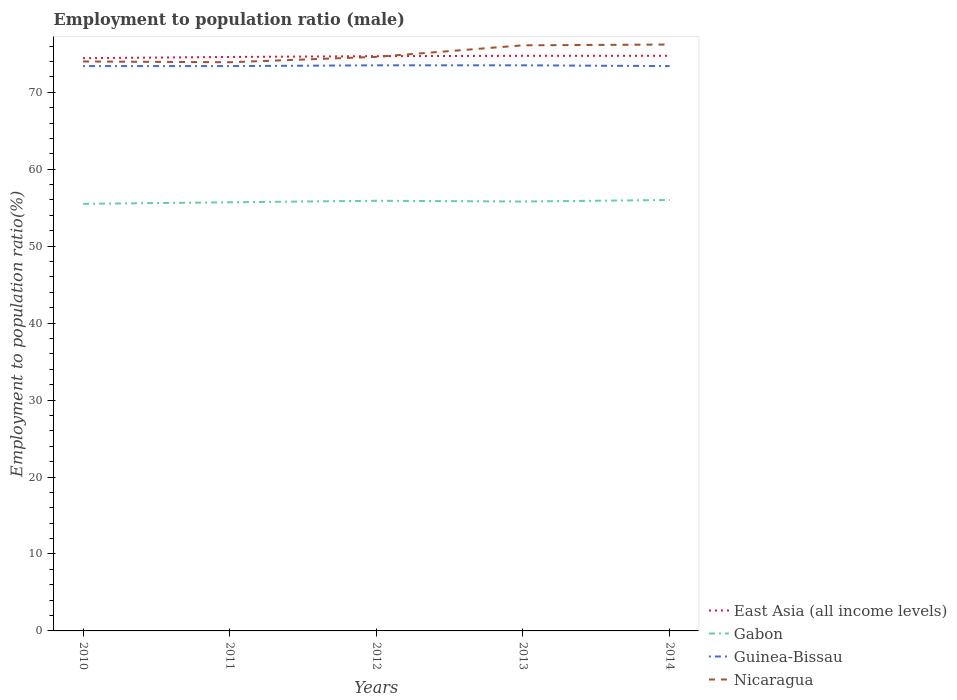How many different coloured lines are there?
Provide a succinct answer. 4. Does the line corresponding to Gabon intersect with the line corresponding to Nicaragua?
Make the answer very short. No. Across all years, what is the maximum employment to population ratio in Gabon?
Offer a terse response. 55.5. What is the total employment to population ratio in Nicaragua in the graph?
Offer a terse response. -0.7. What is the difference between the highest and the second highest employment to population ratio in Nicaragua?
Offer a terse response. 2.3. Is the employment to population ratio in Nicaragua strictly greater than the employment to population ratio in Guinea-Bissau over the years?
Ensure brevity in your answer.  No. How many years are there in the graph?
Provide a succinct answer. 5. Does the graph contain grids?
Keep it short and to the point. No. What is the title of the graph?
Your answer should be very brief. Employment to population ratio (male). Does "Venezuela" appear as one of the legend labels in the graph?
Ensure brevity in your answer.  No. What is the Employment to population ratio(%) of East Asia (all income levels) in 2010?
Offer a terse response. 74.43. What is the Employment to population ratio(%) in Gabon in 2010?
Make the answer very short. 55.5. What is the Employment to population ratio(%) of Guinea-Bissau in 2010?
Give a very brief answer. 73.4. What is the Employment to population ratio(%) of Nicaragua in 2010?
Ensure brevity in your answer.  74. What is the Employment to population ratio(%) of East Asia (all income levels) in 2011?
Provide a short and direct response. 74.59. What is the Employment to population ratio(%) of Gabon in 2011?
Your answer should be very brief. 55.7. What is the Employment to population ratio(%) of Guinea-Bissau in 2011?
Your answer should be compact. 73.4. What is the Employment to population ratio(%) of Nicaragua in 2011?
Your answer should be very brief. 73.9. What is the Employment to population ratio(%) in East Asia (all income levels) in 2012?
Make the answer very short. 74.69. What is the Employment to population ratio(%) of Gabon in 2012?
Ensure brevity in your answer.  55.9. What is the Employment to population ratio(%) of Guinea-Bissau in 2012?
Make the answer very short. 73.5. What is the Employment to population ratio(%) in Nicaragua in 2012?
Provide a succinct answer. 74.6. What is the Employment to population ratio(%) in East Asia (all income levels) in 2013?
Offer a terse response. 74.74. What is the Employment to population ratio(%) in Gabon in 2013?
Keep it short and to the point. 55.8. What is the Employment to population ratio(%) of Guinea-Bissau in 2013?
Offer a terse response. 73.5. What is the Employment to population ratio(%) of Nicaragua in 2013?
Offer a very short reply. 76.1. What is the Employment to population ratio(%) in East Asia (all income levels) in 2014?
Your response must be concise. 74.74. What is the Employment to population ratio(%) of Gabon in 2014?
Your response must be concise. 56. What is the Employment to population ratio(%) in Guinea-Bissau in 2014?
Your answer should be compact. 73.4. What is the Employment to population ratio(%) in Nicaragua in 2014?
Provide a short and direct response. 76.2. Across all years, what is the maximum Employment to population ratio(%) of East Asia (all income levels)?
Your answer should be compact. 74.74. Across all years, what is the maximum Employment to population ratio(%) of Gabon?
Keep it short and to the point. 56. Across all years, what is the maximum Employment to population ratio(%) of Guinea-Bissau?
Provide a succinct answer. 73.5. Across all years, what is the maximum Employment to population ratio(%) in Nicaragua?
Your answer should be very brief. 76.2. Across all years, what is the minimum Employment to population ratio(%) of East Asia (all income levels)?
Your response must be concise. 74.43. Across all years, what is the minimum Employment to population ratio(%) of Gabon?
Your answer should be very brief. 55.5. Across all years, what is the minimum Employment to population ratio(%) of Guinea-Bissau?
Make the answer very short. 73.4. Across all years, what is the minimum Employment to population ratio(%) in Nicaragua?
Provide a short and direct response. 73.9. What is the total Employment to population ratio(%) of East Asia (all income levels) in the graph?
Make the answer very short. 373.17. What is the total Employment to population ratio(%) in Gabon in the graph?
Offer a terse response. 278.9. What is the total Employment to population ratio(%) of Guinea-Bissau in the graph?
Your response must be concise. 367.2. What is the total Employment to population ratio(%) of Nicaragua in the graph?
Ensure brevity in your answer.  374.8. What is the difference between the Employment to population ratio(%) in East Asia (all income levels) in 2010 and that in 2011?
Your response must be concise. -0.16. What is the difference between the Employment to population ratio(%) in Nicaragua in 2010 and that in 2011?
Make the answer very short. 0.1. What is the difference between the Employment to population ratio(%) in East Asia (all income levels) in 2010 and that in 2012?
Your response must be concise. -0.26. What is the difference between the Employment to population ratio(%) in East Asia (all income levels) in 2010 and that in 2013?
Offer a terse response. -0.31. What is the difference between the Employment to population ratio(%) in Gabon in 2010 and that in 2013?
Offer a terse response. -0.3. What is the difference between the Employment to population ratio(%) of Guinea-Bissau in 2010 and that in 2013?
Your response must be concise. -0.1. What is the difference between the Employment to population ratio(%) of Nicaragua in 2010 and that in 2013?
Give a very brief answer. -2.1. What is the difference between the Employment to population ratio(%) of East Asia (all income levels) in 2010 and that in 2014?
Offer a very short reply. -0.31. What is the difference between the Employment to population ratio(%) of Nicaragua in 2010 and that in 2014?
Your answer should be compact. -2.2. What is the difference between the Employment to population ratio(%) in East Asia (all income levels) in 2011 and that in 2012?
Your answer should be compact. -0.1. What is the difference between the Employment to population ratio(%) of Gabon in 2011 and that in 2012?
Provide a succinct answer. -0.2. What is the difference between the Employment to population ratio(%) in Nicaragua in 2011 and that in 2012?
Your answer should be compact. -0.7. What is the difference between the Employment to population ratio(%) of East Asia (all income levels) in 2011 and that in 2013?
Make the answer very short. -0.15. What is the difference between the Employment to population ratio(%) of Guinea-Bissau in 2011 and that in 2013?
Make the answer very short. -0.1. What is the difference between the Employment to population ratio(%) in East Asia (all income levels) in 2011 and that in 2014?
Offer a very short reply. -0.15. What is the difference between the Employment to population ratio(%) in Nicaragua in 2011 and that in 2014?
Keep it short and to the point. -2.3. What is the difference between the Employment to population ratio(%) in East Asia (all income levels) in 2012 and that in 2013?
Provide a short and direct response. -0.05. What is the difference between the Employment to population ratio(%) of Gabon in 2012 and that in 2013?
Offer a terse response. 0.1. What is the difference between the Employment to population ratio(%) of Guinea-Bissau in 2012 and that in 2013?
Your response must be concise. 0. What is the difference between the Employment to population ratio(%) in East Asia (all income levels) in 2012 and that in 2014?
Your answer should be very brief. -0.05. What is the difference between the Employment to population ratio(%) in Guinea-Bissau in 2012 and that in 2014?
Your response must be concise. 0.1. What is the difference between the Employment to population ratio(%) of East Asia (all income levels) in 2013 and that in 2014?
Offer a terse response. -0. What is the difference between the Employment to population ratio(%) of Guinea-Bissau in 2013 and that in 2014?
Give a very brief answer. 0.1. What is the difference between the Employment to population ratio(%) in Nicaragua in 2013 and that in 2014?
Keep it short and to the point. -0.1. What is the difference between the Employment to population ratio(%) of East Asia (all income levels) in 2010 and the Employment to population ratio(%) of Gabon in 2011?
Offer a very short reply. 18.73. What is the difference between the Employment to population ratio(%) of East Asia (all income levels) in 2010 and the Employment to population ratio(%) of Guinea-Bissau in 2011?
Your answer should be very brief. 1.03. What is the difference between the Employment to population ratio(%) in East Asia (all income levels) in 2010 and the Employment to population ratio(%) in Nicaragua in 2011?
Your response must be concise. 0.53. What is the difference between the Employment to population ratio(%) in Gabon in 2010 and the Employment to population ratio(%) in Guinea-Bissau in 2011?
Ensure brevity in your answer.  -17.9. What is the difference between the Employment to population ratio(%) of Gabon in 2010 and the Employment to population ratio(%) of Nicaragua in 2011?
Provide a succinct answer. -18.4. What is the difference between the Employment to population ratio(%) of East Asia (all income levels) in 2010 and the Employment to population ratio(%) of Gabon in 2012?
Your answer should be compact. 18.53. What is the difference between the Employment to population ratio(%) in East Asia (all income levels) in 2010 and the Employment to population ratio(%) in Guinea-Bissau in 2012?
Keep it short and to the point. 0.93. What is the difference between the Employment to population ratio(%) in East Asia (all income levels) in 2010 and the Employment to population ratio(%) in Nicaragua in 2012?
Provide a succinct answer. -0.17. What is the difference between the Employment to population ratio(%) in Gabon in 2010 and the Employment to population ratio(%) in Nicaragua in 2012?
Your answer should be very brief. -19.1. What is the difference between the Employment to population ratio(%) of Guinea-Bissau in 2010 and the Employment to population ratio(%) of Nicaragua in 2012?
Offer a terse response. -1.2. What is the difference between the Employment to population ratio(%) in East Asia (all income levels) in 2010 and the Employment to population ratio(%) in Gabon in 2013?
Your answer should be compact. 18.63. What is the difference between the Employment to population ratio(%) in East Asia (all income levels) in 2010 and the Employment to population ratio(%) in Guinea-Bissau in 2013?
Offer a very short reply. 0.93. What is the difference between the Employment to population ratio(%) in East Asia (all income levels) in 2010 and the Employment to population ratio(%) in Nicaragua in 2013?
Offer a terse response. -1.67. What is the difference between the Employment to population ratio(%) of Gabon in 2010 and the Employment to population ratio(%) of Guinea-Bissau in 2013?
Ensure brevity in your answer.  -18. What is the difference between the Employment to population ratio(%) of Gabon in 2010 and the Employment to population ratio(%) of Nicaragua in 2013?
Give a very brief answer. -20.6. What is the difference between the Employment to population ratio(%) in Guinea-Bissau in 2010 and the Employment to population ratio(%) in Nicaragua in 2013?
Your answer should be compact. -2.7. What is the difference between the Employment to population ratio(%) of East Asia (all income levels) in 2010 and the Employment to population ratio(%) of Gabon in 2014?
Give a very brief answer. 18.43. What is the difference between the Employment to population ratio(%) of East Asia (all income levels) in 2010 and the Employment to population ratio(%) of Guinea-Bissau in 2014?
Make the answer very short. 1.03. What is the difference between the Employment to population ratio(%) in East Asia (all income levels) in 2010 and the Employment to population ratio(%) in Nicaragua in 2014?
Your answer should be very brief. -1.77. What is the difference between the Employment to population ratio(%) in Gabon in 2010 and the Employment to population ratio(%) in Guinea-Bissau in 2014?
Your answer should be compact. -17.9. What is the difference between the Employment to population ratio(%) in Gabon in 2010 and the Employment to population ratio(%) in Nicaragua in 2014?
Offer a terse response. -20.7. What is the difference between the Employment to population ratio(%) in Guinea-Bissau in 2010 and the Employment to population ratio(%) in Nicaragua in 2014?
Your answer should be very brief. -2.8. What is the difference between the Employment to population ratio(%) of East Asia (all income levels) in 2011 and the Employment to population ratio(%) of Gabon in 2012?
Offer a very short reply. 18.69. What is the difference between the Employment to population ratio(%) in East Asia (all income levels) in 2011 and the Employment to population ratio(%) in Guinea-Bissau in 2012?
Offer a very short reply. 1.09. What is the difference between the Employment to population ratio(%) in East Asia (all income levels) in 2011 and the Employment to population ratio(%) in Nicaragua in 2012?
Give a very brief answer. -0.01. What is the difference between the Employment to population ratio(%) of Gabon in 2011 and the Employment to population ratio(%) of Guinea-Bissau in 2012?
Offer a very short reply. -17.8. What is the difference between the Employment to population ratio(%) of Gabon in 2011 and the Employment to population ratio(%) of Nicaragua in 2012?
Make the answer very short. -18.9. What is the difference between the Employment to population ratio(%) in East Asia (all income levels) in 2011 and the Employment to population ratio(%) in Gabon in 2013?
Provide a succinct answer. 18.79. What is the difference between the Employment to population ratio(%) in East Asia (all income levels) in 2011 and the Employment to population ratio(%) in Guinea-Bissau in 2013?
Your answer should be compact. 1.09. What is the difference between the Employment to population ratio(%) in East Asia (all income levels) in 2011 and the Employment to population ratio(%) in Nicaragua in 2013?
Ensure brevity in your answer.  -1.51. What is the difference between the Employment to population ratio(%) in Gabon in 2011 and the Employment to population ratio(%) in Guinea-Bissau in 2013?
Provide a short and direct response. -17.8. What is the difference between the Employment to population ratio(%) in Gabon in 2011 and the Employment to population ratio(%) in Nicaragua in 2013?
Give a very brief answer. -20.4. What is the difference between the Employment to population ratio(%) of Guinea-Bissau in 2011 and the Employment to population ratio(%) of Nicaragua in 2013?
Your answer should be very brief. -2.7. What is the difference between the Employment to population ratio(%) of East Asia (all income levels) in 2011 and the Employment to population ratio(%) of Gabon in 2014?
Your answer should be very brief. 18.59. What is the difference between the Employment to population ratio(%) of East Asia (all income levels) in 2011 and the Employment to population ratio(%) of Guinea-Bissau in 2014?
Offer a terse response. 1.19. What is the difference between the Employment to population ratio(%) of East Asia (all income levels) in 2011 and the Employment to population ratio(%) of Nicaragua in 2014?
Provide a succinct answer. -1.61. What is the difference between the Employment to population ratio(%) of Gabon in 2011 and the Employment to population ratio(%) of Guinea-Bissau in 2014?
Offer a very short reply. -17.7. What is the difference between the Employment to population ratio(%) of Gabon in 2011 and the Employment to population ratio(%) of Nicaragua in 2014?
Offer a terse response. -20.5. What is the difference between the Employment to population ratio(%) in Guinea-Bissau in 2011 and the Employment to population ratio(%) in Nicaragua in 2014?
Provide a short and direct response. -2.8. What is the difference between the Employment to population ratio(%) in East Asia (all income levels) in 2012 and the Employment to population ratio(%) in Gabon in 2013?
Offer a terse response. 18.89. What is the difference between the Employment to population ratio(%) of East Asia (all income levels) in 2012 and the Employment to population ratio(%) of Guinea-Bissau in 2013?
Your response must be concise. 1.19. What is the difference between the Employment to population ratio(%) in East Asia (all income levels) in 2012 and the Employment to population ratio(%) in Nicaragua in 2013?
Ensure brevity in your answer.  -1.41. What is the difference between the Employment to population ratio(%) in Gabon in 2012 and the Employment to population ratio(%) in Guinea-Bissau in 2013?
Keep it short and to the point. -17.6. What is the difference between the Employment to population ratio(%) in Gabon in 2012 and the Employment to population ratio(%) in Nicaragua in 2013?
Offer a terse response. -20.2. What is the difference between the Employment to population ratio(%) of Guinea-Bissau in 2012 and the Employment to population ratio(%) of Nicaragua in 2013?
Your answer should be very brief. -2.6. What is the difference between the Employment to population ratio(%) of East Asia (all income levels) in 2012 and the Employment to population ratio(%) of Gabon in 2014?
Give a very brief answer. 18.69. What is the difference between the Employment to population ratio(%) of East Asia (all income levels) in 2012 and the Employment to population ratio(%) of Guinea-Bissau in 2014?
Your answer should be compact. 1.29. What is the difference between the Employment to population ratio(%) of East Asia (all income levels) in 2012 and the Employment to population ratio(%) of Nicaragua in 2014?
Give a very brief answer. -1.51. What is the difference between the Employment to population ratio(%) in Gabon in 2012 and the Employment to population ratio(%) in Guinea-Bissau in 2014?
Your answer should be compact. -17.5. What is the difference between the Employment to population ratio(%) of Gabon in 2012 and the Employment to population ratio(%) of Nicaragua in 2014?
Keep it short and to the point. -20.3. What is the difference between the Employment to population ratio(%) in East Asia (all income levels) in 2013 and the Employment to population ratio(%) in Gabon in 2014?
Provide a short and direct response. 18.74. What is the difference between the Employment to population ratio(%) of East Asia (all income levels) in 2013 and the Employment to population ratio(%) of Guinea-Bissau in 2014?
Provide a succinct answer. 1.34. What is the difference between the Employment to population ratio(%) in East Asia (all income levels) in 2013 and the Employment to population ratio(%) in Nicaragua in 2014?
Ensure brevity in your answer.  -1.46. What is the difference between the Employment to population ratio(%) of Gabon in 2013 and the Employment to population ratio(%) of Guinea-Bissau in 2014?
Your answer should be very brief. -17.6. What is the difference between the Employment to population ratio(%) in Gabon in 2013 and the Employment to population ratio(%) in Nicaragua in 2014?
Provide a succinct answer. -20.4. What is the average Employment to population ratio(%) in East Asia (all income levels) per year?
Provide a short and direct response. 74.64. What is the average Employment to population ratio(%) of Gabon per year?
Offer a very short reply. 55.78. What is the average Employment to population ratio(%) of Guinea-Bissau per year?
Your response must be concise. 73.44. What is the average Employment to population ratio(%) of Nicaragua per year?
Your answer should be compact. 74.96. In the year 2010, what is the difference between the Employment to population ratio(%) of East Asia (all income levels) and Employment to population ratio(%) of Gabon?
Provide a succinct answer. 18.93. In the year 2010, what is the difference between the Employment to population ratio(%) of East Asia (all income levels) and Employment to population ratio(%) of Guinea-Bissau?
Keep it short and to the point. 1.03. In the year 2010, what is the difference between the Employment to population ratio(%) of East Asia (all income levels) and Employment to population ratio(%) of Nicaragua?
Keep it short and to the point. 0.43. In the year 2010, what is the difference between the Employment to population ratio(%) in Gabon and Employment to population ratio(%) in Guinea-Bissau?
Offer a very short reply. -17.9. In the year 2010, what is the difference between the Employment to population ratio(%) of Gabon and Employment to population ratio(%) of Nicaragua?
Your answer should be very brief. -18.5. In the year 2011, what is the difference between the Employment to population ratio(%) of East Asia (all income levels) and Employment to population ratio(%) of Gabon?
Offer a terse response. 18.89. In the year 2011, what is the difference between the Employment to population ratio(%) in East Asia (all income levels) and Employment to population ratio(%) in Guinea-Bissau?
Keep it short and to the point. 1.19. In the year 2011, what is the difference between the Employment to population ratio(%) of East Asia (all income levels) and Employment to population ratio(%) of Nicaragua?
Provide a short and direct response. 0.69. In the year 2011, what is the difference between the Employment to population ratio(%) in Gabon and Employment to population ratio(%) in Guinea-Bissau?
Provide a short and direct response. -17.7. In the year 2011, what is the difference between the Employment to population ratio(%) of Gabon and Employment to population ratio(%) of Nicaragua?
Ensure brevity in your answer.  -18.2. In the year 2011, what is the difference between the Employment to population ratio(%) in Guinea-Bissau and Employment to population ratio(%) in Nicaragua?
Your answer should be compact. -0.5. In the year 2012, what is the difference between the Employment to population ratio(%) in East Asia (all income levels) and Employment to population ratio(%) in Gabon?
Your answer should be compact. 18.79. In the year 2012, what is the difference between the Employment to population ratio(%) in East Asia (all income levels) and Employment to population ratio(%) in Guinea-Bissau?
Offer a very short reply. 1.19. In the year 2012, what is the difference between the Employment to population ratio(%) of East Asia (all income levels) and Employment to population ratio(%) of Nicaragua?
Your answer should be very brief. 0.09. In the year 2012, what is the difference between the Employment to population ratio(%) of Gabon and Employment to population ratio(%) of Guinea-Bissau?
Provide a short and direct response. -17.6. In the year 2012, what is the difference between the Employment to population ratio(%) in Gabon and Employment to population ratio(%) in Nicaragua?
Provide a short and direct response. -18.7. In the year 2013, what is the difference between the Employment to population ratio(%) of East Asia (all income levels) and Employment to population ratio(%) of Gabon?
Your answer should be very brief. 18.94. In the year 2013, what is the difference between the Employment to population ratio(%) in East Asia (all income levels) and Employment to population ratio(%) in Guinea-Bissau?
Provide a succinct answer. 1.24. In the year 2013, what is the difference between the Employment to population ratio(%) of East Asia (all income levels) and Employment to population ratio(%) of Nicaragua?
Offer a terse response. -1.36. In the year 2013, what is the difference between the Employment to population ratio(%) in Gabon and Employment to population ratio(%) in Guinea-Bissau?
Your answer should be compact. -17.7. In the year 2013, what is the difference between the Employment to population ratio(%) of Gabon and Employment to population ratio(%) of Nicaragua?
Your answer should be compact. -20.3. In the year 2014, what is the difference between the Employment to population ratio(%) in East Asia (all income levels) and Employment to population ratio(%) in Gabon?
Your answer should be very brief. 18.74. In the year 2014, what is the difference between the Employment to population ratio(%) of East Asia (all income levels) and Employment to population ratio(%) of Guinea-Bissau?
Your answer should be very brief. 1.34. In the year 2014, what is the difference between the Employment to population ratio(%) of East Asia (all income levels) and Employment to population ratio(%) of Nicaragua?
Offer a terse response. -1.46. In the year 2014, what is the difference between the Employment to population ratio(%) in Gabon and Employment to population ratio(%) in Guinea-Bissau?
Offer a very short reply. -17.4. In the year 2014, what is the difference between the Employment to population ratio(%) in Gabon and Employment to population ratio(%) in Nicaragua?
Offer a very short reply. -20.2. What is the ratio of the Employment to population ratio(%) in East Asia (all income levels) in 2010 to that in 2011?
Your answer should be very brief. 1. What is the ratio of the Employment to population ratio(%) of Guinea-Bissau in 2010 to that in 2011?
Provide a short and direct response. 1. What is the ratio of the Employment to population ratio(%) in Gabon in 2010 to that in 2012?
Provide a succinct answer. 0.99. What is the ratio of the Employment to population ratio(%) in Guinea-Bissau in 2010 to that in 2012?
Ensure brevity in your answer.  1. What is the ratio of the Employment to population ratio(%) of Gabon in 2010 to that in 2013?
Make the answer very short. 0.99. What is the ratio of the Employment to population ratio(%) of Guinea-Bissau in 2010 to that in 2013?
Give a very brief answer. 1. What is the ratio of the Employment to population ratio(%) in Nicaragua in 2010 to that in 2013?
Offer a very short reply. 0.97. What is the ratio of the Employment to population ratio(%) of East Asia (all income levels) in 2010 to that in 2014?
Provide a short and direct response. 1. What is the ratio of the Employment to population ratio(%) of Gabon in 2010 to that in 2014?
Offer a very short reply. 0.99. What is the ratio of the Employment to population ratio(%) of Nicaragua in 2010 to that in 2014?
Provide a short and direct response. 0.97. What is the ratio of the Employment to population ratio(%) of Nicaragua in 2011 to that in 2012?
Your response must be concise. 0.99. What is the ratio of the Employment to population ratio(%) of Guinea-Bissau in 2011 to that in 2013?
Provide a short and direct response. 1. What is the ratio of the Employment to population ratio(%) in Nicaragua in 2011 to that in 2013?
Keep it short and to the point. 0.97. What is the ratio of the Employment to population ratio(%) in Gabon in 2011 to that in 2014?
Make the answer very short. 0.99. What is the ratio of the Employment to population ratio(%) of Guinea-Bissau in 2011 to that in 2014?
Keep it short and to the point. 1. What is the ratio of the Employment to population ratio(%) in Nicaragua in 2011 to that in 2014?
Offer a terse response. 0.97. What is the ratio of the Employment to population ratio(%) in Gabon in 2012 to that in 2013?
Ensure brevity in your answer.  1. What is the ratio of the Employment to population ratio(%) in Guinea-Bissau in 2012 to that in 2013?
Provide a succinct answer. 1. What is the ratio of the Employment to population ratio(%) of Nicaragua in 2012 to that in 2013?
Provide a short and direct response. 0.98. What is the ratio of the Employment to population ratio(%) of Guinea-Bissau in 2012 to that in 2014?
Offer a terse response. 1. What is the ratio of the Employment to population ratio(%) of Nicaragua in 2012 to that in 2014?
Make the answer very short. 0.98. What is the ratio of the Employment to population ratio(%) of Gabon in 2013 to that in 2014?
Give a very brief answer. 1. What is the ratio of the Employment to population ratio(%) of Nicaragua in 2013 to that in 2014?
Give a very brief answer. 1. What is the difference between the highest and the second highest Employment to population ratio(%) in East Asia (all income levels)?
Ensure brevity in your answer.  0. What is the difference between the highest and the second highest Employment to population ratio(%) of Gabon?
Offer a terse response. 0.1. What is the difference between the highest and the second highest Employment to population ratio(%) in Guinea-Bissau?
Give a very brief answer. 0. What is the difference between the highest and the lowest Employment to population ratio(%) in East Asia (all income levels)?
Make the answer very short. 0.31. What is the difference between the highest and the lowest Employment to population ratio(%) of Gabon?
Give a very brief answer. 0.5. What is the difference between the highest and the lowest Employment to population ratio(%) of Guinea-Bissau?
Provide a succinct answer. 0.1. What is the difference between the highest and the lowest Employment to population ratio(%) of Nicaragua?
Keep it short and to the point. 2.3. 